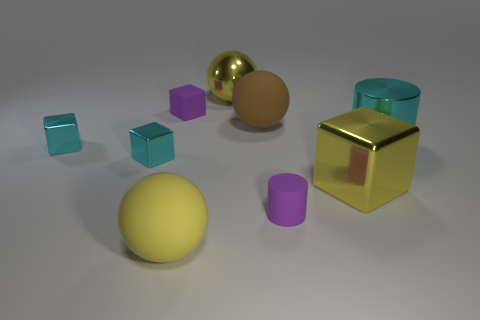The cylinder that is made of the same material as the purple block is what size?
Provide a short and direct response. Small. Do the big metallic cube and the shiny ball have the same color?
Make the answer very short. Yes. There is a thing that is to the right of the large brown sphere and in front of the big yellow metallic block; what shape is it?
Your answer should be very brief. Cylinder. How many purple rubber objects are on the right side of the purple rubber thing behind the cyan shiny cylinder?
Offer a very short reply. 1. How many things are either large yellow metallic things right of the big brown ball or large gray balls?
Ensure brevity in your answer.  1. There is a yellow shiny thing that is right of the yellow metallic sphere; what is its size?
Offer a terse response. Large. What is the yellow cube made of?
Ensure brevity in your answer.  Metal. What is the shape of the tiny purple rubber thing behind the yellow metal cube in front of the big cyan cylinder?
Your answer should be very brief. Cube. What number of other objects are there of the same shape as the big brown object?
Provide a short and direct response. 2. There is a small purple cube; are there any brown objects behind it?
Your answer should be very brief. No. 